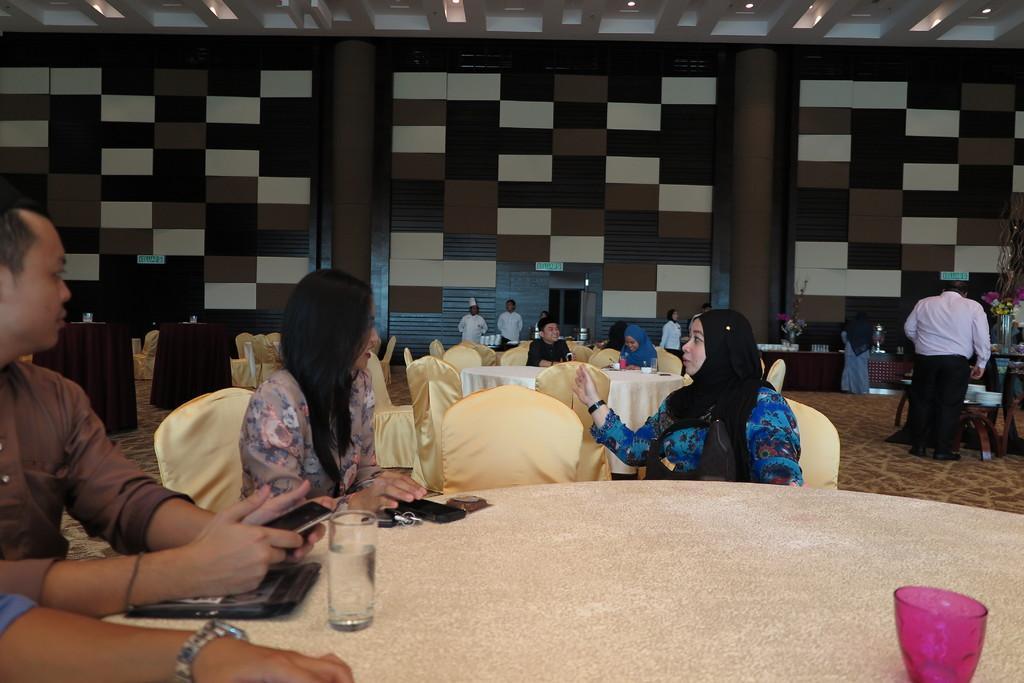Describe this image in one or two sentences. There are three persons sitting in the front. On the left corner a person is holding a mobile. There is a table. On the table there are glasses, mobile, keys and some other items. Also a person is wearing a watch. In the background there are many chairs, tables, some persons are sitting, standing. And there is a check wall on the background. 